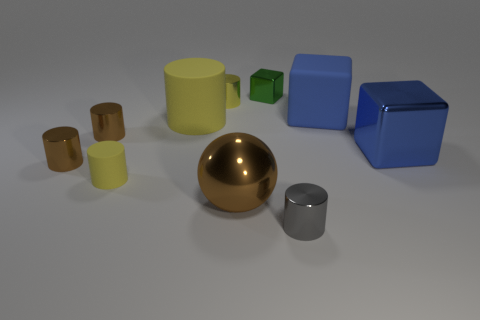There is a small object on the right side of the cube that is on the left side of the gray object; is there a matte block that is behind it?
Your response must be concise. Yes. What number of objects are small brown cylinders behind the large metallic block or brown metal objects behind the blue metallic block?
Ensure brevity in your answer.  1. Is the big blue object in front of the large yellow thing made of the same material as the large cylinder?
Offer a very short reply. No. There is a tiny thing that is in front of the large yellow matte cylinder and on the right side of the big brown metal object; what material is it?
Ensure brevity in your answer.  Metal. There is a large metal thing that is left of the tiny metallic cylinder in front of the large ball; what is its color?
Your answer should be compact. Brown. What is the material of the tiny green thing that is the same shape as the big blue rubber object?
Offer a terse response. Metal. There is a tiny metal cylinder that is right of the cylinder behind the big matte object that is on the left side of the small green metal thing; what color is it?
Your response must be concise. Gray. What number of objects are either large gray rubber cylinders or small gray metal things?
Your response must be concise. 1. How many small brown objects are the same shape as the big yellow thing?
Offer a terse response. 2. Does the green object have the same material as the big object that is to the left of the large brown shiny sphere?
Keep it short and to the point. No. 